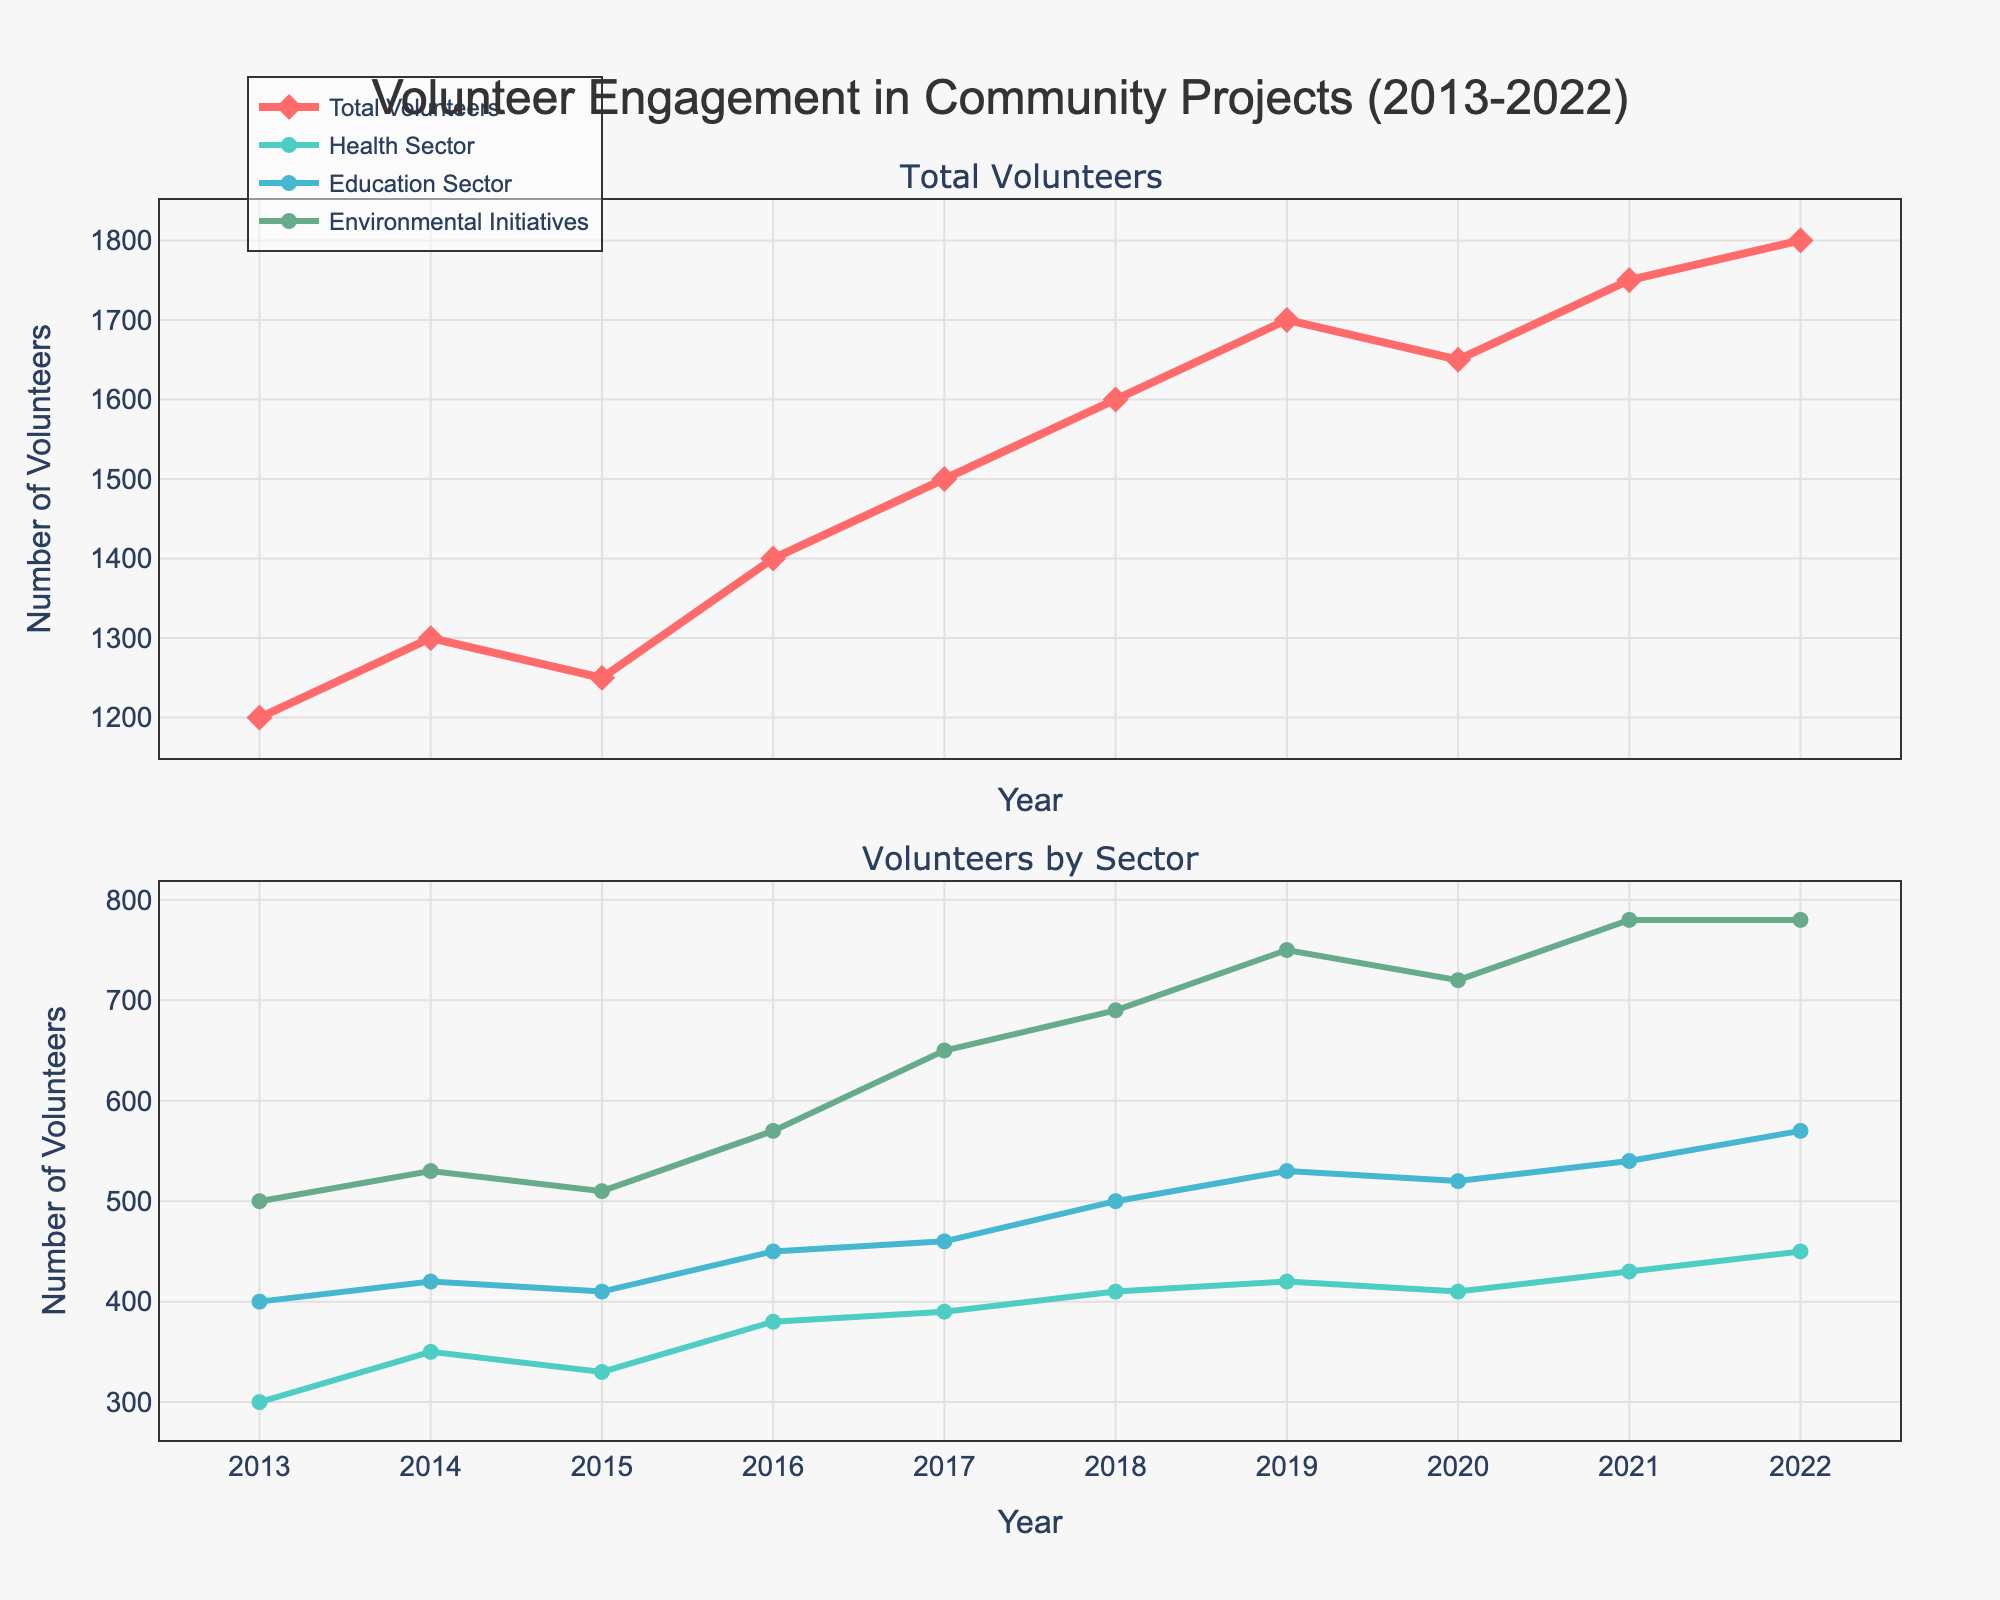What is the title of the figure? The title of the figure is displayed at the top of the plot, reading 'Volunteer Engagement in Community Projects (2013-2022)'.
Answer: Volunteer Engagement in Community Projects (2013-2022) How many total volunteers were there in 2019? The number for total volunteers in 2019 can be obtained directly from the plot's data points or legend.
Answer: 1700 Which sector had the highest number of volunteers in 2022? By looking at the endpoints of the lines for different sectors in the year 2022, Environmental Initiatives had the highest number of volunteers.
Answer: Environmental Initiatives By how much did the total number of volunteers increase from 2013 to 2022? Subtract the total number of volunteers in 2013 from that in 2022: 1800 - 1200.
Answer: 600 What is the trend in total volunteers from 2016 to 2019? Analyze the slope of the line for total volunteers between 2016 and 2019. It is consistently upward, indicating an increase.
Answer: Increasing Which sector saw the greatest increase in volunteer numbers from 2013 to 2022? Calculate the difference for each sector from 2013 to 2022, noting that Environmental Initiatives had a significant increase from 500 to 780.
Answer: Environmental Initiatives In which year did the Health Sector have the lowest number of volunteers? Find the point corresponding to the lowest number of Health Sector volunteers in the plot, occurring in 2013.
Answer: 2013 What is the average number of volunteers in the Education Sector over the decade? Add all the volunteer numbers for the Education Sector from 2013 to 2022 (400+420+410+450+460+500+530+520+540+570=4700), and then divide by the number of years (10).
Answer: 470 How do the volunteer trends in the Health Sector and Environmental Initiatives compare? Compare the slopes and directions of the lines for the Health Sector and Environmental Initiatives. Both trends are upward, but Environmental Initiatives has a steeper increase.
Answer: Both increasing, Environmental Initiatives more steeply What was the trend in volunteer numbers in the Environmental Initiatives during 2020? Observe the data point for Environmental Initiatives in 2020: it decreased slightly from 750 to 720.
Answer: Decreasing 